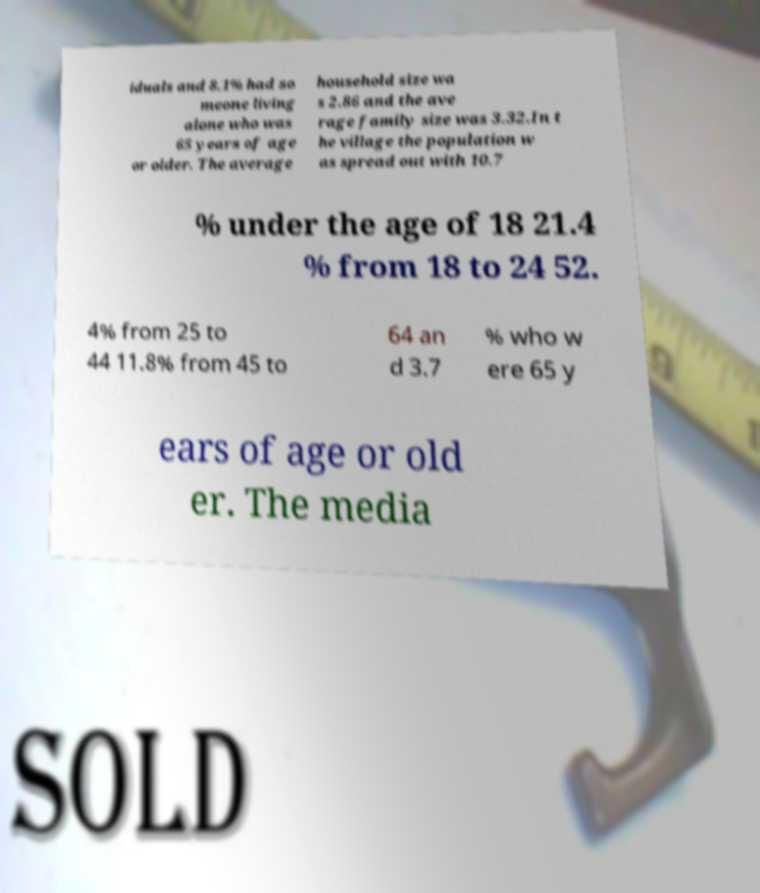I need the written content from this picture converted into text. Can you do that? iduals and 8.1% had so meone living alone who was 65 years of age or older. The average household size wa s 2.86 and the ave rage family size was 3.32.In t he village the population w as spread out with 10.7 % under the age of 18 21.4 % from 18 to 24 52. 4% from 25 to 44 11.8% from 45 to 64 an d 3.7 % who w ere 65 y ears of age or old er. The media 